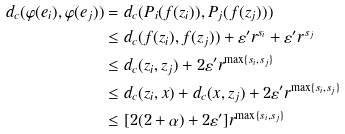Convert formula to latex. <formula><loc_0><loc_0><loc_500><loc_500>d _ { c } ( \varphi ( e _ { i } ) , \varphi ( e _ { j } ) ) & = d _ { c } ( P _ { i } ( f ( z _ { i } ) ) , P _ { j } ( f ( z _ { j } ) ) ) \\ & \leq d _ { c } ( f ( z _ { i } ) , f ( z _ { j } ) ) + \varepsilon ^ { \prime } r ^ { s _ { i } } + \varepsilon ^ { \prime } r ^ { s _ { j } } \\ & \leq d _ { c } ( z _ { i } , z _ { j } ) + 2 \varepsilon ^ { \prime } r ^ { \max \{ s _ { i } , s _ { j } \} } \\ & \leq d _ { c } ( z _ { i } , x ) + d _ { c } ( x , z _ { j } ) + 2 \varepsilon ^ { \prime } r ^ { \max \{ s _ { i } , s _ { j } \} } \\ & \leq [ 2 ( 2 + \alpha ) + 2 \varepsilon ^ { \prime } ] r ^ { \max \{ s _ { i } , s _ { j } \} }</formula> 